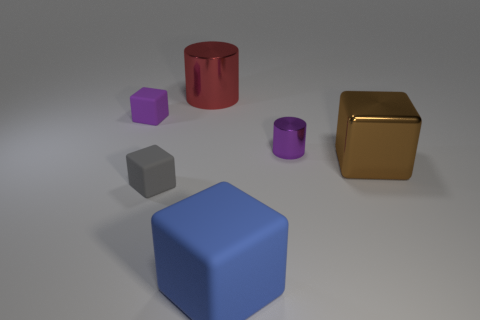Are there more small things behind the small purple metallic thing than big red shiny objects that are behind the red metal cylinder?
Your answer should be compact. Yes. What size is the matte cube that is the same color as the small shiny cylinder?
Keep it short and to the point. Small. There is a brown cube; does it have the same size as the block left of the gray rubber block?
Your response must be concise. No. How many spheres are either brown objects or red metal objects?
Offer a very short reply. 0. There is a cube that is the same material as the tiny cylinder; what is its size?
Your answer should be compact. Large. Is the size of the metal cylinder in front of the purple matte cube the same as the cube that is right of the large blue block?
Your answer should be very brief. No. How many objects are either large yellow rubber objects or small gray cubes?
Ensure brevity in your answer.  1. What is the shape of the big blue rubber object?
Make the answer very short. Cube. What size is the brown shiny object that is the same shape as the gray object?
Your answer should be very brief. Large. What is the size of the cylinder that is to the right of the large red metallic object that is left of the tiny purple cylinder?
Provide a succinct answer. Small. 